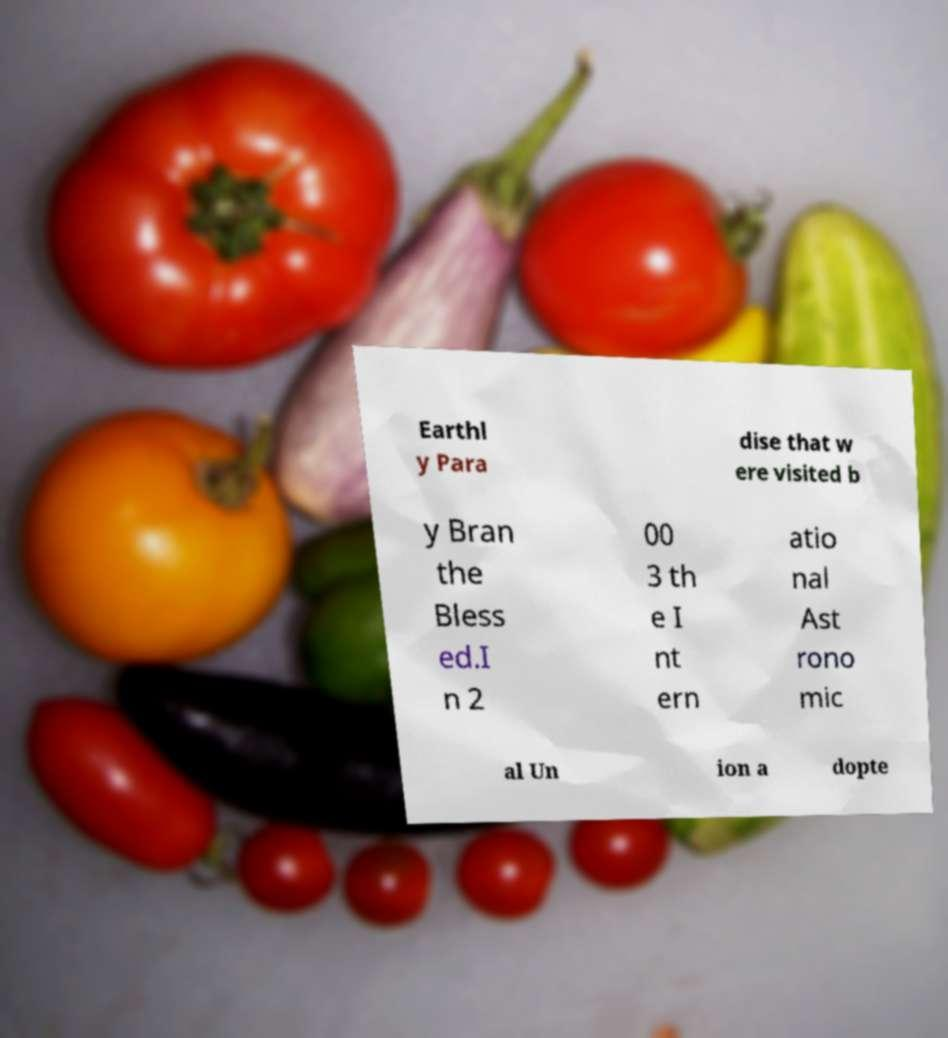Please identify and transcribe the text found in this image. Earthl y Para dise that w ere visited b y Bran the Bless ed.I n 2 00 3 th e I nt ern atio nal Ast rono mic al Un ion a dopte 